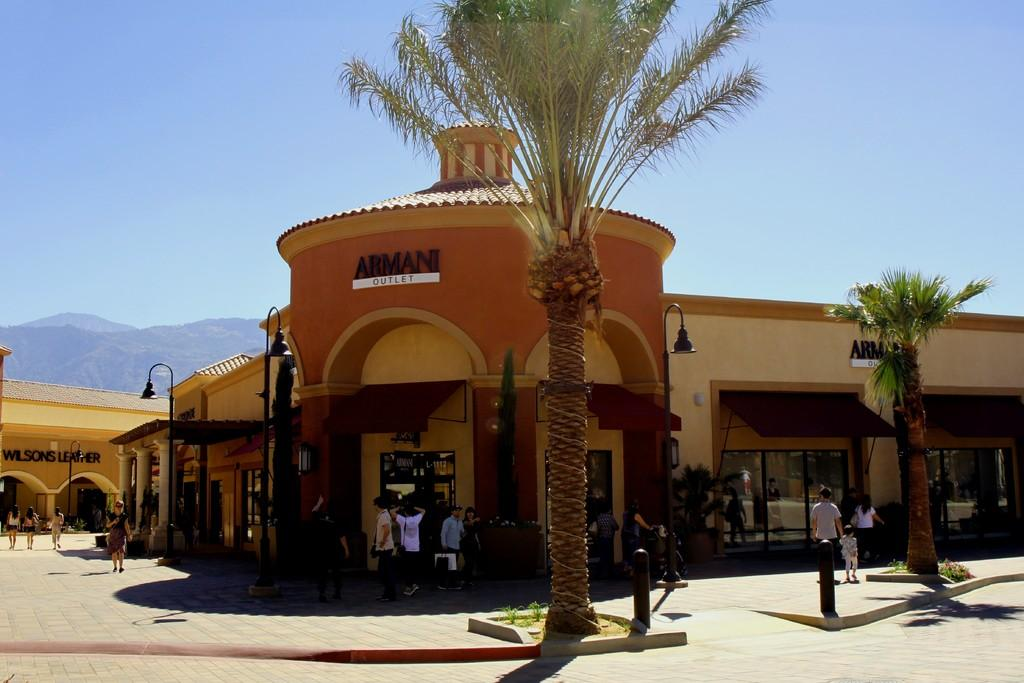What type of structure is present in the image? There is a building in the image. What natural elements can be seen in the image? There are trees in the image. What are the people in the image doing? There are people walking in the image. What can be seen in the distance in the image? There are hills visible in the background of the image. Where is the basketball court located in the image? There is no basketball court present in the image. What type of shop can be seen in the image? There is no shop present in the image. 